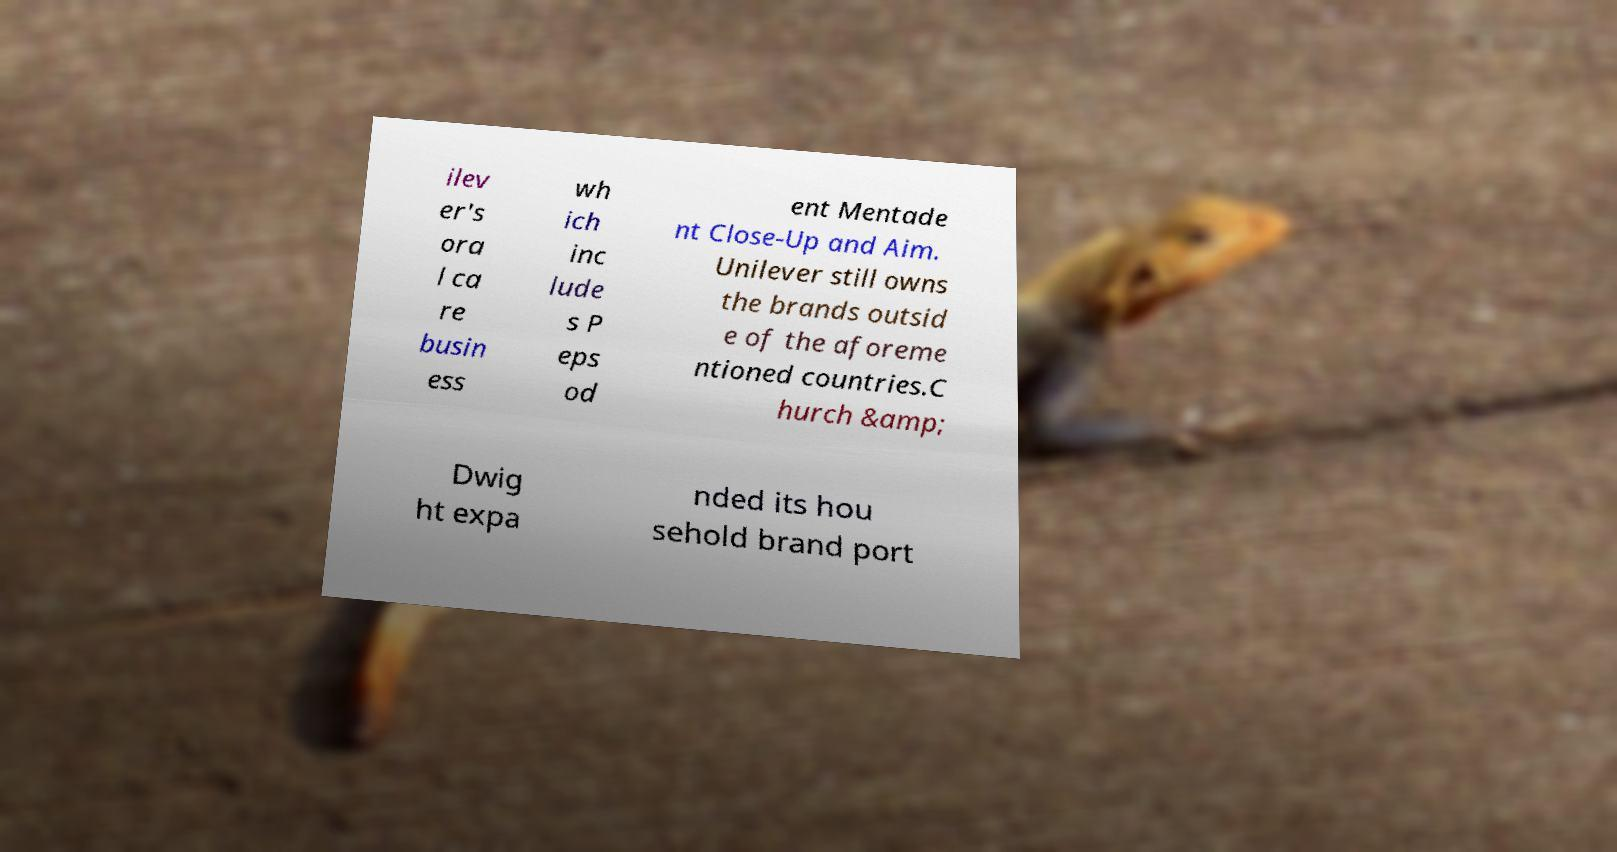For documentation purposes, I need the text within this image transcribed. Could you provide that? ilev er's ora l ca re busin ess wh ich inc lude s P eps od ent Mentade nt Close-Up and Aim. Unilever still owns the brands outsid e of the aforeme ntioned countries.C hurch &amp; Dwig ht expa nded its hou sehold brand port 